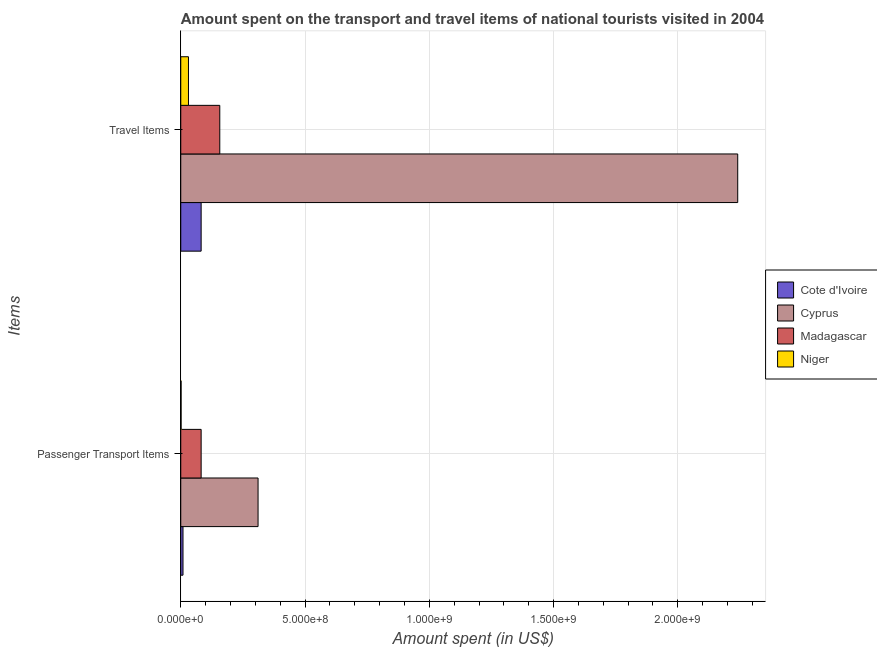How many different coloured bars are there?
Your response must be concise. 4. How many groups of bars are there?
Provide a succinct answer. 2. Are the number of bars per tick equal to the number of legend labels?
Your response must be concise. Yes. How many bars are there on the 2nd tick from the top?
Provide a succinct answer. 4. What is the label of the 2nd group of bars from the top?
Keep it short and to the point. Passenger Transport Items. What is the amount spent in travel items in Cyprus?
Keep it short and to the point. 2.24e+09. Across all countries, what is the maximum amount spent in travel items?
Your response must be concise. 2.24e+09. Across all countries, what is the minimum amount spent in travel items?
Give a very brief answer. 3.10e+07. In which country was the amount spent in travel items maximum?
Provide a succinct answer. Cyprus. In which country was the amount spent in travel items minimum?
Make the answer very short. Niger. What is the total amount spent on passenger transport items in the graph?
Your answer should be compact. 4.03e+08. What is the difference between the amount spent on passenger transport items in Niger and that in Madagascar?
Keep it short and to the point. -8.07e+07. What is the difference between the amount spent on passenger transport items in Cyprus and the amount spent in travel items in Cote d'Ivoire?
Provide a short and direct response. 2.29e+08. What is the average amount spent on passenger transport items per country?
Provide a short and direct response. 1.01e+08. What is the difference between the amount spent on passenger transport items and amount spent in travel items in Cote d'Ivoire?
Offer a very short reply. -7.30e+07. In how many countries, is the amount spent in travel items greater than 1500000000 US$?
Your answer should be compact. 1. What is the ratio of the amount spent on passenger transport items in Madagascar to that in Cote d'Ivoire?
Your answer should be compact. 9.11. Is the amount spent in travel items in Madagascar less than that in Cyprus?
Offer a very short reply. Yes. In how many countries, is the amount spent in travel items greater than the average amount spent in travel items taken over all countries?
Your answer should be very brief. 1. What does the 2nd bar from the top in Passenger Transport Items represents?
Your answer should be compact. Madagascar. What does the 4th bar from the bottom in Passenger Transport Items represents?
Give a very brief answer. Niger. How many bars are there?
Ensure brevity in your answer.  8. How many countries are there in the graph?
Offer a terse response. 4. Are the values on the major ticks of X-axis written in scientific E-notation?
Make the answer very short. Yes. Does the graph contain grids?
Provide a succinct answer. Yes. How are the legend labels stacked?
Offer a terse response. Vertical. What is the title of the graph?
Provide a short and direct response. Amount spent on the transport and travel items of national tourists visited in 2004. Does "Russian Federation" appear as one of the legend labels in the graph?
Make the answer very short. No. What is the label or title of the X-axis?
Your answer should be compact. Amount spent (in US$). What is the label or title of the Y-axis?
Your response must be concise. Items. What is the Amount spent (in US$) in Cote d'Ivoire in Passenger Transport Items?
Ensure brevity in your answer.  9.00e+06. What is the Amount spent (in US$) in Cyprus in Passenger Transport Items?
Your answer should be compact. 3.11e+08. What is the Amount spent (in US$) of Madagascar in Passenger Transport Items?
Offer a very short reply. 8.20e+07. What is the Amount spent (in US$) in Niger in Passenger Transport Items?
Your response must be concise. 1.30e+06. What is the Amount spent (in US$) in Cote d'Ivoire in Travel Items?
Your answer should be very brief. 8.20e+07. What is the Amount spent (in US$) of Cyprus in Travel Items?
Your response must be concise. 2.24e+09. What is the Amount spent (in US$) in Madagascar in Travel Items?
Your answer should be compact. 1.57e+08. What is the Amount spent (in US$) in Niger in Travel Items?
Your answer should be compact. 3.10e+07. Across all Items, what is the maximum Amount spent (in US$) of Cote d'Ivoire?
Provide a short and direct response. 8.20e+07. Across all Items, what is the maximum Amount spent (in US$) of Cyprus?
Your response must be concise. 2.24e+09. Across all Items, what is the maximum Amount spent (in US$) of Madagascar?
Keep it short and to the point. 1.57e+08. Across all Items, what is the maximum Amount spent (in US$) in Niger?
Your answer should be compact. 3.10e+07. Across all Items, what is the minimum Amount spent (in US$) in Cote d'Ivoire?
Provide a short and direct response. 9.00e+06. Across all Items, what is the minimum Amount spent (in US$) in Cyprus?
Ensure brevity in your answer.  3.11e+08. Across all Items, what is the minimum Amount spent (in US$) in Madagascar?
Offer a very short reply. 8.20e+07. Across all Items, what is the minimum Amount spent (in US$) in Niger?
Offer a terse response. 1.30e+06. What is the total Amount spent (in US$) in Cote d'Ivoire in the graph?
Keep it short and to the point. 9.10e+07. What is the total Amount spent (in US$) of Cyprus in the graph?
Ensure brevity in your answer.  2.55e+09. What is the total Amount spent (in US$) in Madagascar in the graph?
Ensure brevity in your answer.  2.39e+08. What is the total Amount spent (in US$) of Niger in the graph?
Offer a terse response. 3.23e+07. What is the difference between the Amount spent (in US$) of Cote d'Ivoire in Passenger Transport Items and that in Travel Items?
Ensure brevity in your answer.  -7.30e+07. What is the difference between the Amount spent (in US$) of Cyprus in Passenger Transport Items and that in Travel Items?
Your answer should be compact. -1.93e+09. What is the difference between the Amount spent (in US$) in Madagascar in Passenger Transport Items and that in Travel Items?
Give a very brief answer. -7.50e+07. What is the difference between the Amount spent (in US$) in Niger in Passenger Transport Items and that in Travel Items?
Provide a succinct answer. -2.97e+07. What is the difference between the Amount spent (in US$) in Cote d'Ivoire in Passenger Transport Items and the Amount spent (in US$) in Cyprus in Travel Items?
Make the answer very short. -2.23e+09. What is the difference between the Amount spent (in US$) of Cote d'Ivoire in Passenger Transport Items and the Amount spent (in US$) of Madagascar in Travel Items?
Ensure brevity in your answer.  -1.48e+08. What is the difference between the Amount spent (in US$) of Cote d'Ivoire in Passenger Transport Items and the Amount spent (in US$) of Niger in Travel Items?
Make the answer very short. -2.20e+07. What is the difference between the Amount spent (in US$) in Cyprus in Passenger Transport Items and the Amount spent (in US$) in Madagascar in Travel Items?
Offer a terse response. 1.54e+08. What is the difference between the Amount spent (in US$) of Cyprus in Passenger Transport Items and the Amount spent (in US$) of Niger in Travel Items?
Offer a terse response. 2.80e+08. What is the difference between the Amount spent (in US$) in Madagascar in Passenger Transport Items and the Amount spent (in US$) in Niger in Travel Items?
Offer a terse response. 5.10e+07. What is the average Amount spent (in US$) of Cote d'Ivoire per Items?
Your answer should be compact. 4.55e+07. What is the average Amount spent (in US$) of Cyprus per Items?
Keep it short and to the point. 1.28e+09. What is the average Amount spent (in US$) of Madagascar per Items?
Your answer should be compact. 1.20e+08. What is the average Amount spent (in US$) of Niger per Items?
Offer a very short reply. 1.62e+07. What is the difference between the Amount spent (in US$) in Cote d'Ivoire and Amount spent (in US$) in Cyprus in Passenger Transport Items?
Make the answer very short. -3.02e+08. What is the difference between the Amount spent (in US$) in Cote d'Ivoire and Amount spent (in US$) in Madagascar in Passenger Transport Items?
Offer a terse response. -7.30e+07. What is the difference between the Amount spent (in US$) of Cote d'Ivoire and Amount spent (in US$) of Niger in Passenger Transport Items?
Give a very brief answer. 7.70e+06. What is the difference between the Amount spent (in US$) in Cyprus and Amount spent (in US$) in Madagascar in Passenger Transport Items?
Your answer should be very brief. 2.29e+08. What is the difference between the Amount spent (in US$) in Cyprus and Amount spent (in US$) in Niger in Passenger Transport Items?
Offer a terse response. 3.10e+08. What is the difference between the Amount spent (in US$) of Madagascar and Amount spent (in US$) of Niger in Passenger Transport Items?
Provide a short and direct response. 8.07e+07. What is the difference between the Amount spent (in US$) in Cote d'Ivoire and Amount spent (in US$) in Cyprus in Travel Items?
Keep it short and to the point. -2.16e+09. What is the difference between the Amount spent (in US$) of Cote d'Ivoire and Amount spent (in US$) of Madagascar in Travel Items?
Your answer should be very brief. -7.50e+07. What is the difference between the Amount spent (in US$) in Cote d'Ivoire and Amount spent (in US$) in Niger in Travel Items?
Your answer should be compact. 5.10e+07. What is the difference between the Amount spent (in US$) of Cyprus and Amount spent (in US$) of Madagascar in Travel Items?
Your response must be concise. 2.08e+09. What is the difference between the Amount spent (in US$) in Cyprus and Amount spent (in US$) in Niger in Travel Items?
Your answer should be very brief. 2.21e+09. What is the difference between the Amount spent (in US$) in Madagascar and Amount spent (in US$) in Niger in Travel Items?
Provide a succinct answer. 1.26e+08. What is the ratio of the Amount spent (in US$) of Cote d'Ivoire in Passenger Transport Items to that in Travel Items?
Provide a short and direct response. 0.11. What is the ratio of the Amount spent (in US$) of Cyprus in Passenger Transport Items to that in Travel Items?
Your response must be concise. 0.14. What is the ratio of the Amount spent (in US$) of Madagascar in Passenger Transport Items to that in Travel Items?
Your response must be concise. 0.52. What is the ratio of the Amount spent (in US$) of Niger in Passenger Transport Items to that in Travel Items?
Your answer should be compact. 0.04. What is the difference between the highest and the second highest Amount spent (in US$) of Cote d'Ivoire?
Your answer should be compact. 7.30e+07. What is the difference between the highest and the second highest Amount spent (in US$) in Cyprus?
Your answer should be compact. 1.93e+09. What is the difference between the highest and the second highest Amount spent (in US$) of Madagascar?
Offer a very short reply. 7.50e+07. What is the difference between the highest and the second highest Amount spent (in US$) of Niger?
Provide a succinct answer. 2.97e+07. What is the difference between the highest and the lowest Amount spent (in US$) of Cote d'Ivoire?
Provide a succinct answer. 7.30e+07. What is the difference between the highest and the lowest Amount spent (in US$) in Cyprus?
Provide a succinct answer. 1.93e+09. What is the difference between the highest and the lowest Amount spent (in US$) of Madagascar?
Your answer should be very brief. 7.50e+07. What is the difference between the highest and the lowest Amount spent (in US$) in Niger?
Provide a succinct answer. 2.97e+07. 